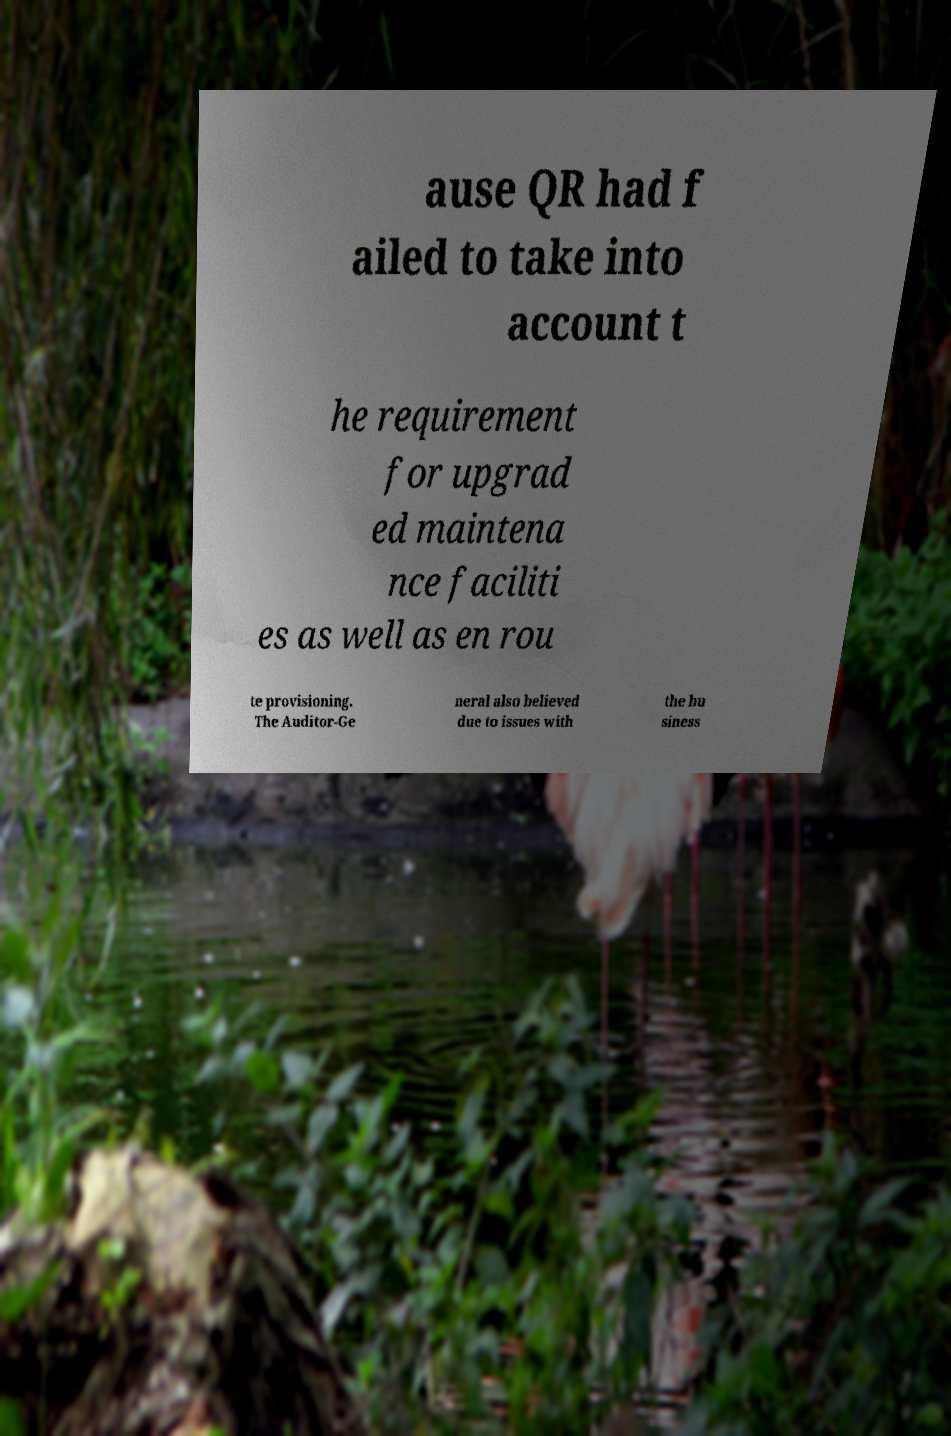What messages or text are displayed in this image? I need them in a readable, typed format. ause QR had f ailed to take into account t he requirement for upgrad ed maintena nce faciliti es as well as en rou te provisioning. The Auditor-Ge neral also believed due to issues with the bu siness 